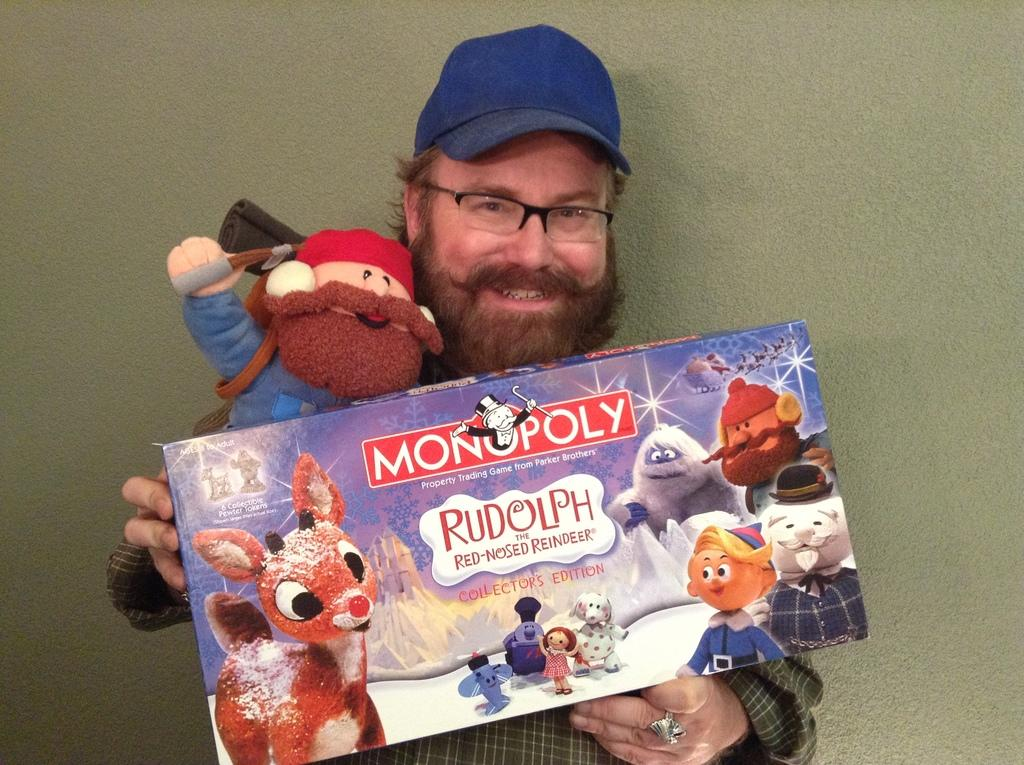What is the main subject of the image? The main subject of the image is a man. Can you describe what the man is wearing on his head? The man is wearing a cap. What is the man doing in the image? The man is standing. What objects is the man holding in the image? The man is holding a doll and a packet. How many sheets are visible in the image? There are no sheets present in the image. What type of produce is the man holding in the image? The man is not holding any produce in the image; he is holding a doll and a packet. 